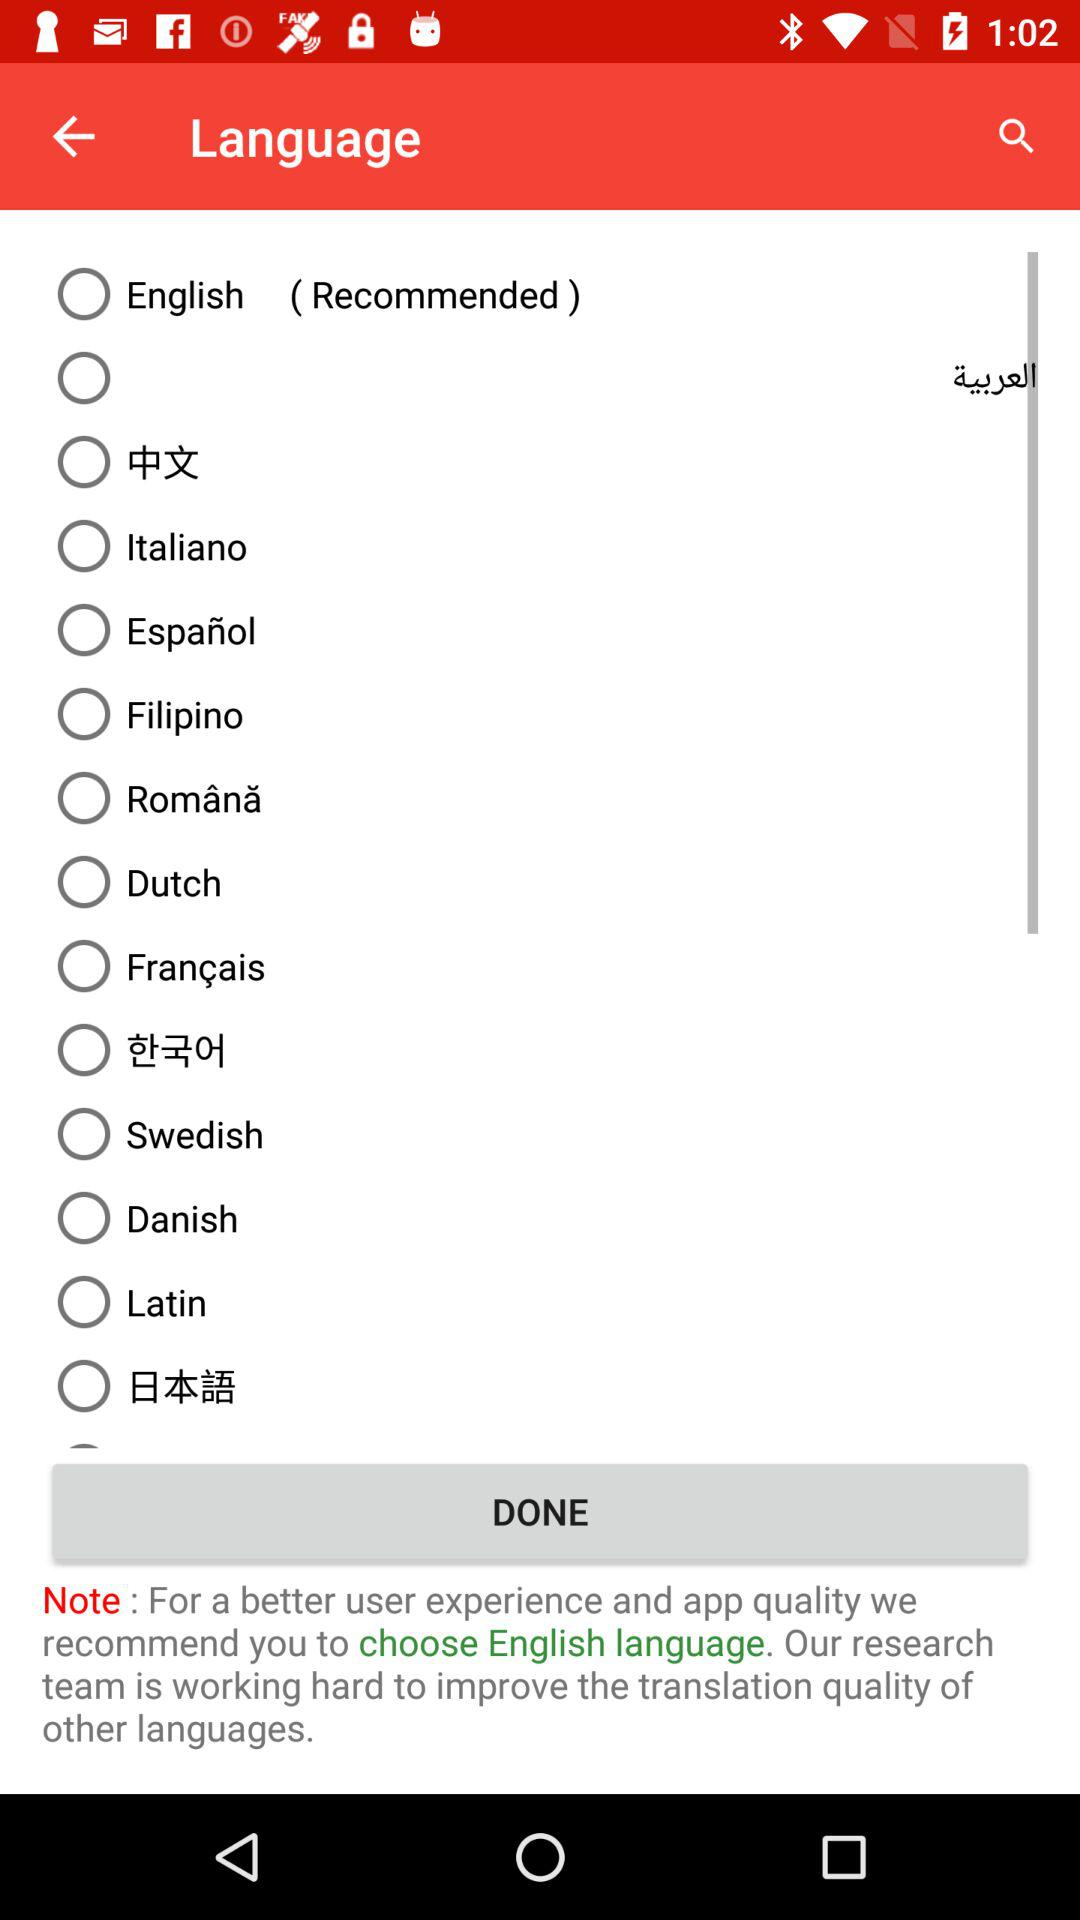What other languages are there?
When the provided information is insufficient, respond with <no answer>. <no answer> 